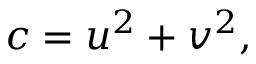<formula> <loc_0><loc_0><loc_500><loc_500>c = u ^ { 2 } + v ^ { 2 } ,</formula> 